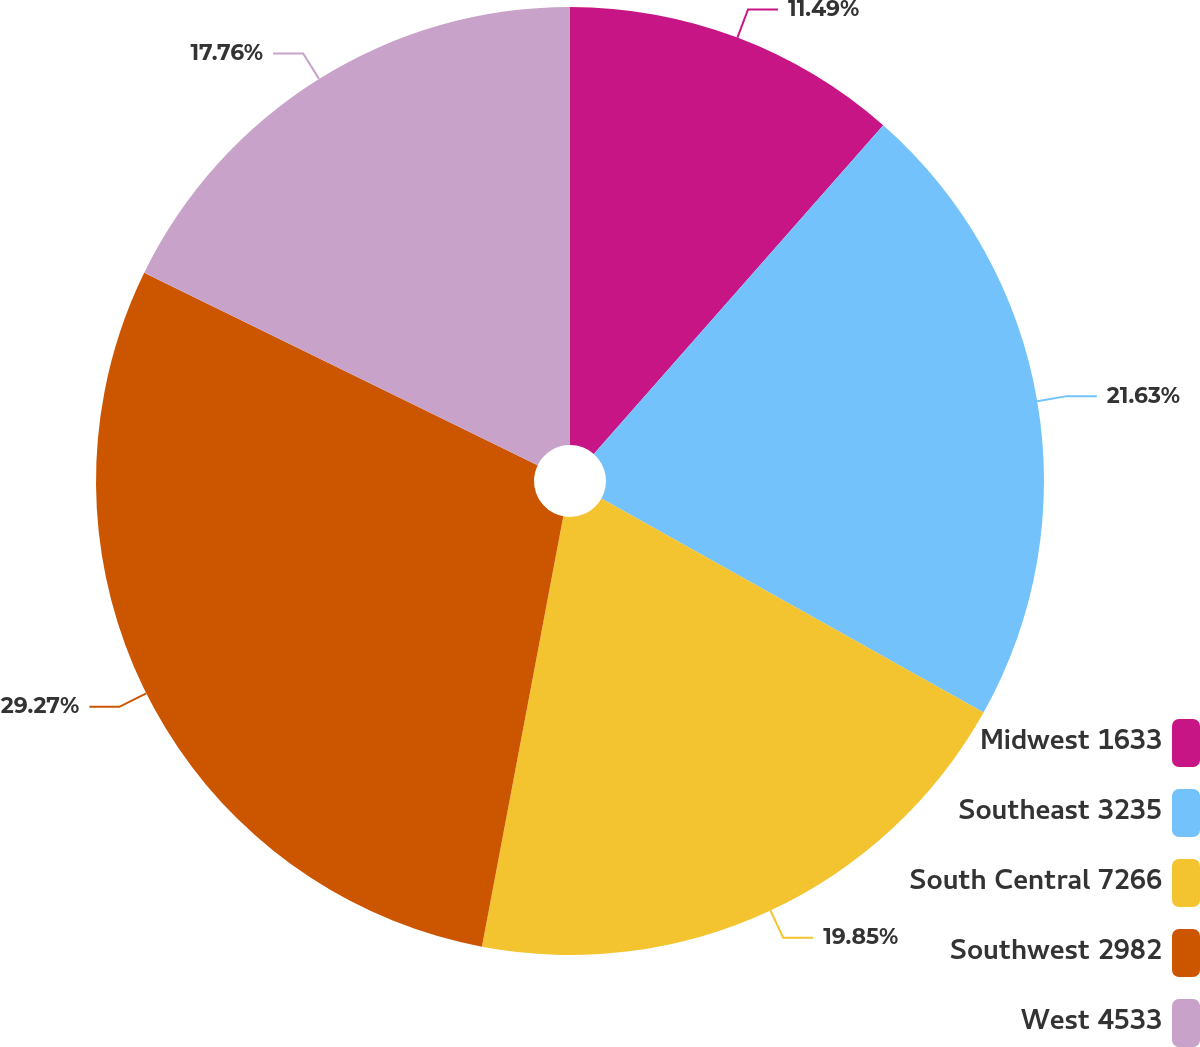Convert chart. <chart><loc_0><loc_0><loc_500><loc_500><pie_chart><fcel>Midwest 1633<fcel>Southeast 3235<fcel>South Central 7266<fcel>Southwest 2982<fcel>West 4533<nl><fcel>11.49%<fcel>21.63%<fcel>19.85%<fcel>29.26%<fcel>17.76%<nl></chart> 